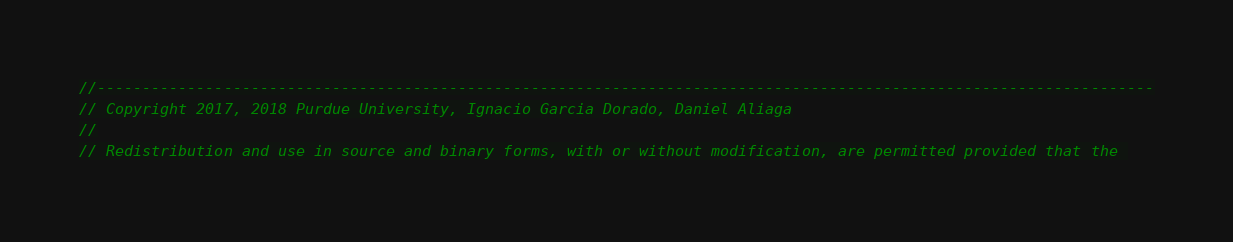<code> <loc_0><loc_0><loc_500><loc_500><_Cuda_>//---------------------------------------------------------------------------------------------------------------------
// Copyright 2017, 2018 Purdue University, Ignacio Garcia Dorado, Daniel Aliaga
//
// Redistribution and use in source and binary forms, with or without modification, are permitted provided that the </code> 